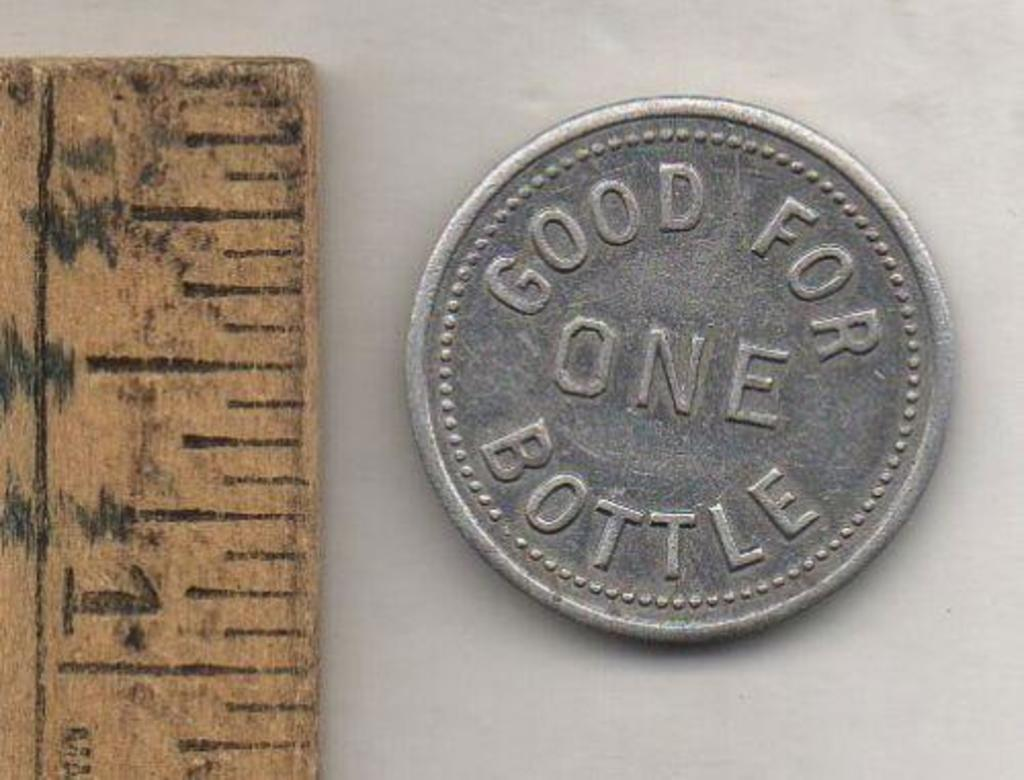Provide a one-sentence caption for the provided image. a ruler next to a coin that says good for one bottle. 